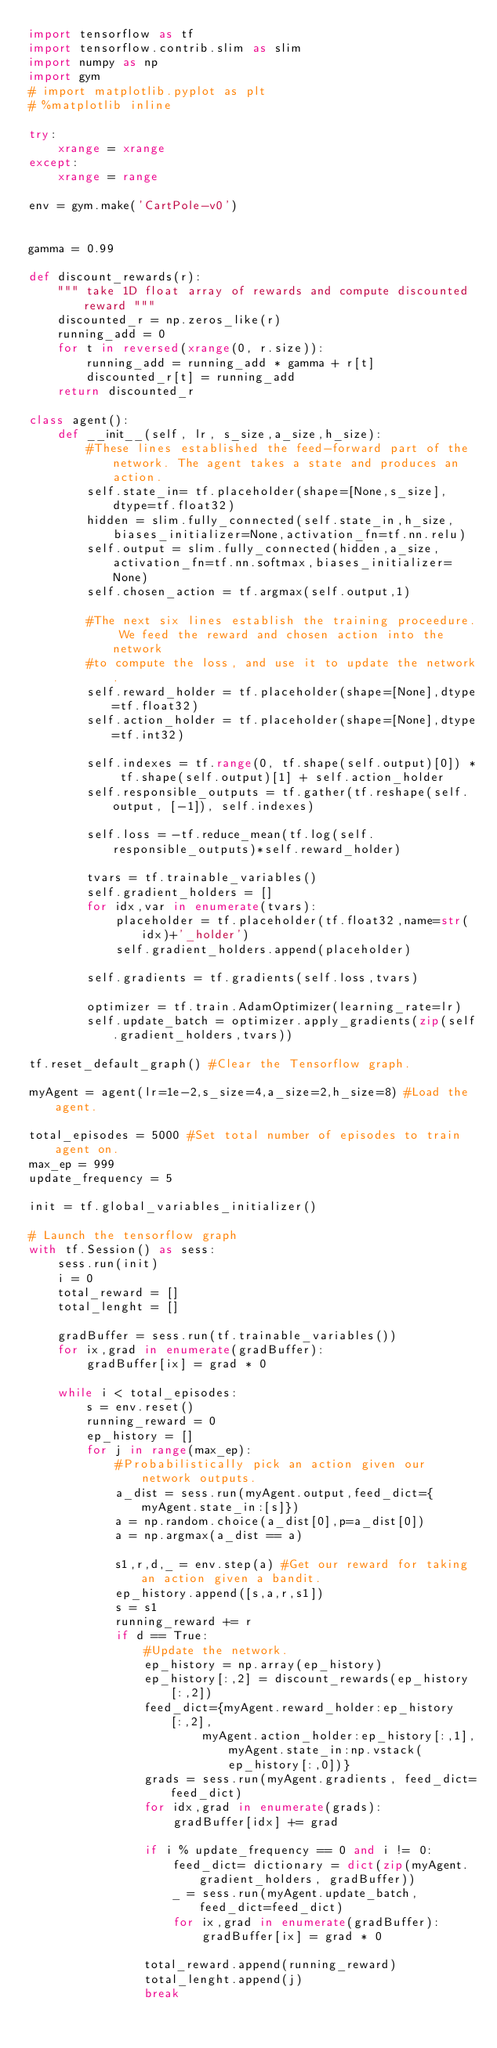<code> <loc_0><loc_0><loc_500><loc_500><_Python_>import tensorflow as tf
import tensorflow.contrib.slim as slim
import numpy as np
import gym
# import matplotlib.pyplot as plt
# %matplotlib inline

try:
    xrange = xrange
except:
    xrange = range

env = gym.make('CartPole-v0')


gamma = 0.99

def discount_rewards(r):
    """ take 1D float array of rewards and compute discounted reward """
    discounted_r = np.zeros_like(r)
    running_add = 0
    for t in reversed(xrange(0, r.size)):
        running_add = running_add * gamma + r[t]
        discounted_r[t] = running_add
    return discounted_r

class agent():
    def __init__(self, lr, s_size,a_size,h_size):
        #These lines established the feed-forward part of the network. The agent takes a state and produces an action.
        self.state_in= tf.placeholder(shape=[None,s_size],dtype=tf.float32)
        hidden = slim.fully_connected(self.state_in,h_size,biases_initializer=None,activation_fn=tf.nn.relu)
        self.output = slim.fully_connected(hidden,a_size,activation_fn=tf.nn.softmax,biases_initializer=None)
        self.chosen_action = tf.argmax(self.output,1)

        #The next six lines establish the training proceedure. We feed the reward and chosen action into the network
        #to compute the loss, and use it to update the network.
        self.reward_holder = tf.placeholder(shape=[None],dtype=tf.float32)
        self.action_holder = tf.placeholder(shape=[None],dtype=tf.int32)
        
        self.indexes = tf.range(0, tf.shape(self.output)[0]) * tf.shape(self.output)[1] + self.action_holder
        self.responsible_outputs = tf.gather(tf.reshape(self.output, [-1]), self.indexes)

        self.loss = -tf.reduce_mean(tf.log(self.responsible_outputs)*self.reward_holder)
        
        tvars = tf.trainable_variables()
        self.gradient_holders = []
        for idx,var in enumerate(tvars):
            placeholder = tf.placeholder(tf.float32,name=str(idx)+'_holder')
            self.gradient_holders.append(placeholder)
        
        self.gradients = tf.gradients(self.loss,tvars)
        
        optimizer = tf.train.AdamOptimizer(learning_rate=lr)
        self.update_batch = optimizer.apply_gradients(zip(self.gradient_holders,tvars))

tf.reset_default_graph() #Clear the Tensorflow graph.

myAgent = agent(lr=1e-2,s_size=4,a_size=2,h_size=8) #Load the agent.

total_episodes = 5000 #Set total number of episodes to train agent on.
max_ep = 999
update_frequency = 5

init = tf.global_variables_initializer()

# Launch the tensorflow graph
with tf.Session() as sess:
    sess.run(init)
    i = 0
    total_reward = []
    total_lenght = []
        
    gradBuffer = sess.run(tf.trainable_variables())
    for ix,grad in enumerate(gradBuffer):
        gradBuffer[ix] = grad * 0
        
    while i < total_episodes:
        s = env.reset()
        running_reward = 0
        ep_history = []
        for j in range(max_ep):
            #Probabilistically pick an action given our network outputs.
            a_dist = sess.run(myAgent.output,feed_dict={myAgent.state_in:[s]})
            a = np.random.choice(a_dist[0],p=a_dist[0])
            a = np.argmax(a_dist == a)

            s1,r,d,_ = env.step(a) #Get our reward for taking an action given a bandit.
            ep_history.append([s,a,r,s1])
            s = s1
            running_reward += r
            if d == True:
                #Update the network.
                ep_history = np.array(ep_history)
                ep_history[:,2] = discount_rewards(ep_history[:,2])
                feed_dict={myAgent.reward_holder:ep_history[:,2],
                        myAgent.action_holder:ep_history[:,1],myAgent.state_in:np.vstack(ep_history[:,0])}
                grads = sess.run(myAgent.gradients, feed_dict=feed_dict)
                for idx,grad in enumerate(grads):
                    gradBuffer[idx] += grad

                if i % update_frequency == 0 and i != 0:
                    feed_dict= dictionary = dict(zip(myAgent.gradient_holders, gradBuffer))
                    _ = sess.run(myAgent.update_batch, feed_dict=feed_dict)
                    for ix,grad in enumerate(gradBuffer):
                        gradBuffer[ix] = grad * 0
                
                total_reward.append(running_reward)
                total_lenght.append(j)
                break

        </code> 